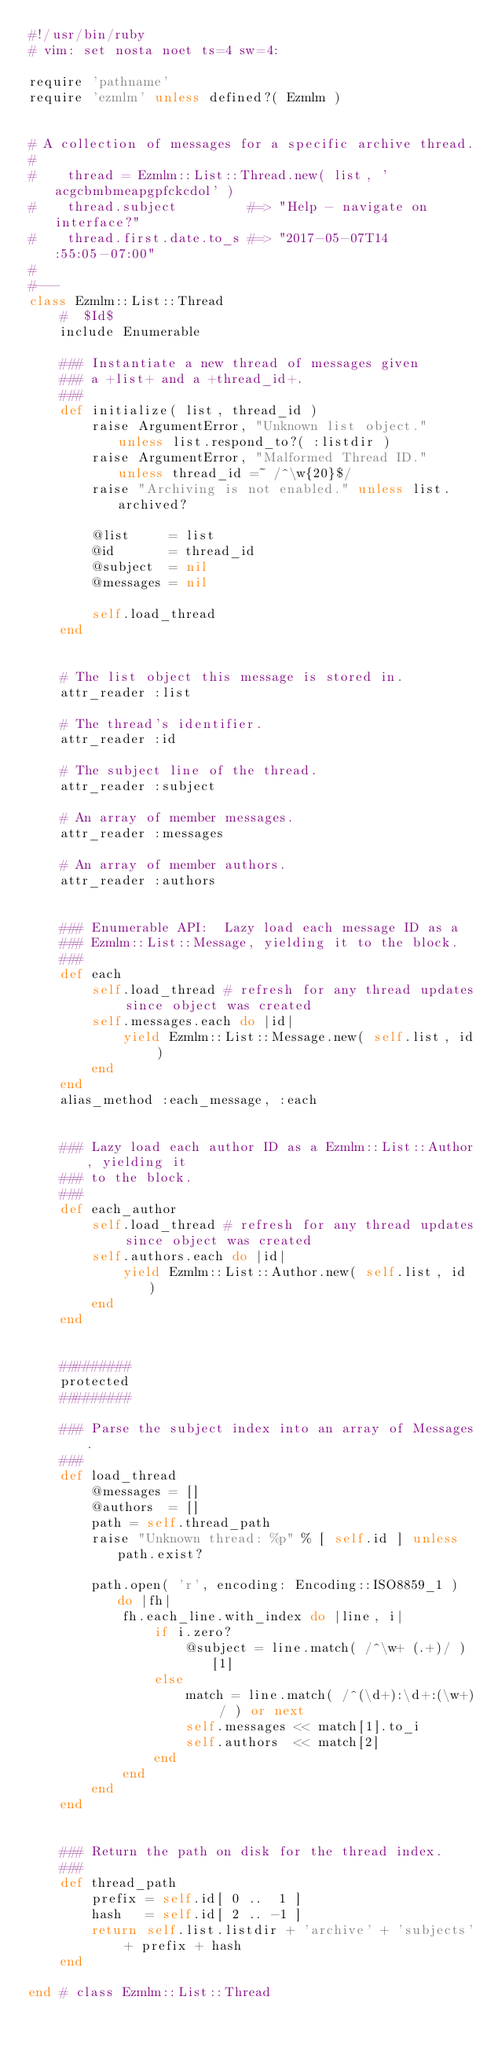Convert code to text. <code><loc_0><loc_0><loc_500><loc_500><_Ruby_>#!/usr/bin/ruby
# vim: set nosta noet ts=4 sw=4:

require 'pathname'
require 'ezmlm' unless defined?( Ezmlm )


# A collection of messages for a specific archive thread.
#
#    thread = Ezmlm::List::Thread.new( list, 'acgcbmbmeapgpfckcdol' )
#    thread.subject         #=> "Help - navigate on interface?"
#    thread.first.date.to_s #=> "2017-05-07T14:55:05-07:00"
#
#---
class Ezmlm::List::Thread
	#  $Id$
	include Enumerable

	### Instantiate a new thread of messages given
	### a +list+ and a +thread_id+.
	###
	def initialize( list, thread_id )
		raise ArgumentError, "Unknown list object." unless list.respond_to?( :listdir )
		raise ArgumentError, "Malformed Thread ID." unless thread_id =~ /^\w{20}$/
		raise "Archiving is not enabled." unless list.archived?

		@list     = list
		@id       = thread_id
		@subject  = nil
		@messages = nil

		self.load_thread
	end


	# The list object this message is stored in.
	attr_reader :list

	# The thread's identifier.
	attr_reader :id

	# The subject line of the thread.
	attr_reader :subject

	# An array of member messages.
	attr_reader :messages

	# An array of member authors.
	attr_reader :authors


	### Enumerable API:  Lazy load each message ID as a
	### Ezmlm::List::Message, yielding it to the block.
	###
	def each
		self.load_thread # refresh for any thread updates since object was created
		self.messages.each do |id|
			yield Ezmlm::List::Message.new( self.list, id )
		end
	end
	alias_method :each_message, :each


	### Lazy load each author ID as a Ezmlm::List::Author, yielding it
	### to the block.
	###
	def each_author
		self.load_thread # refresh for any thread updates since object was created
		self.authors.each do |id|
			yield Ezmlm::List::Author.new( self.list, id )
		end
	end


	#########
	protected
	#########

	### Parse the subject index into an array of Messages.
	###
	def load_thread
		@messages = []
		@authors  = []
		path = self.thread_path
		raise "Unknown thread: %p" % [ self.id ] unless path.exist?

		path.open( 'r', encoding: Encoding::ISO8859_1 ) do |fh|
			fh.each_line.with_index do |line, i|
				if i.zero?
					@subject = line.match( /^\w+ (.+)/ )[1]
				else
					match = line.match( /^(\d+):\d+:(\w+) / ) or next
					self.messages << match[1].to_i
					self.authors  << match[2]
				end
			end
		end
	end


	### Return the path on disk for the thread index.
	###
	def thread_path
		prefix = self.id[ 0 ..  1 ]
		hash   = self.id[ 2 .. -1 ]
		return self.list.listdir + 'archive' + 'subjects' + prefix + hash
	end

end # class Ezmlm::List::Thread
</code> 